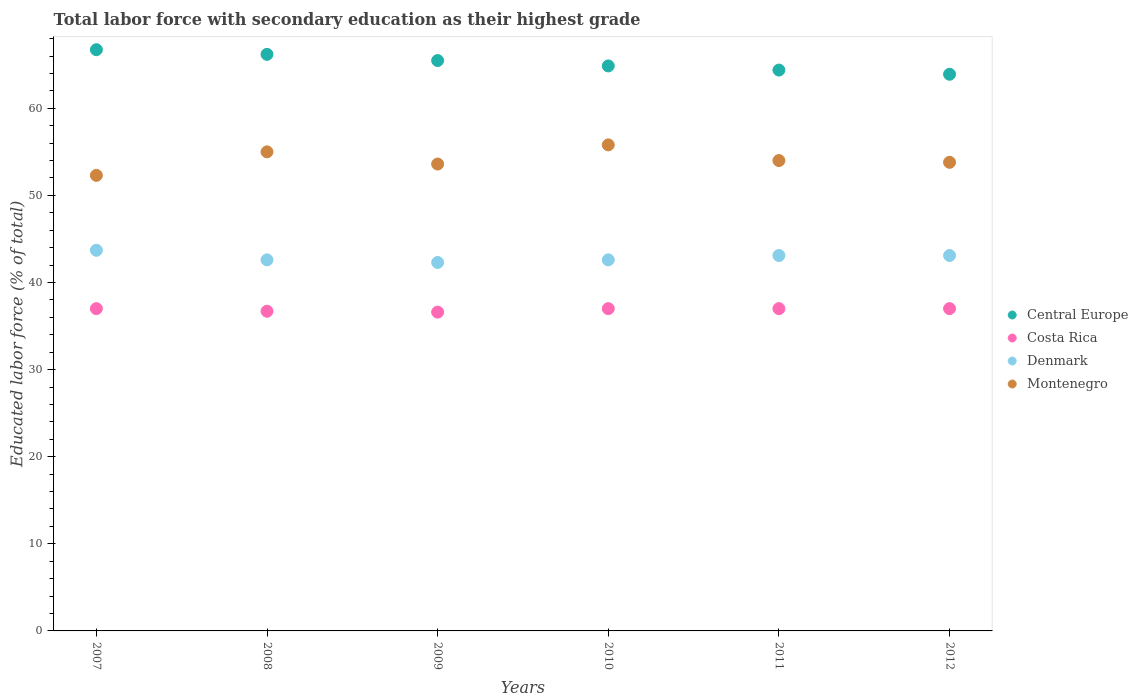How many different coloured dotlines are there?
Your response must be concise. 4. Is the number of dotlines equal to the number of legend labels?
Provide a short and direct response. Yes. What is the percentage of total labor force with primary education in Denmark in 2007?
Make the answer very short. 43.7. Across all years, what is the maximum percentage of total labor force with primary education in Montenegro?
Ensure brevity in your answer.  55.8. Across all years, what is the minimum percentage of total labor force with primary education in Central Europe?
Provide a succinct answer. 63.91. In which year was the percentage of total labor force with primary education in Central Europe maximum?
Your answer should be compact. 2007. In which year was the percentage of total labor force with primary education in Central Europe minimum?
Your answer should be compact. 2012. What is the total percentage of total labor force with primary education in Costa Rica in the graph?
Ensure brevity in your answer.  221.3. What is the difference between the percentage of total labor force with primary education in Montenegro in 2010 and that in 2011?
Your response must be concise. 1.8. What is the difference between the percentage of total labor force with primary education in Central Europe in 2007 and the percentage of total labor force with primary education in Costa Rica in 2010?
Provide a short and direct response. 29.73. What is the average percentage of total labor force with primary education in Montenegro per year?
Keep it short and to the point. 54.08. In the year 2007, what is the difference between the percentage of total labor force with primary education in Montenegro and percentage of total labor force with primary education in Denmark?
Make the answer very short. 8.6. What is the ratio of the percentage of total labor force with primary education in Denmark in 2007 to that in 2011?
Keep it short and to the point. 1.01. What is the difference between the highest and the second highest percentage of total labor force with primary education in Denmark?
Your response must be concise. 0.6. What is the difference between the highest and the lowest percentage of total labor force with primary education in Costa Rica?
Offer a terse response. 0.4. Is the sum of the percentage of total labor force with primary education in Denmark in 2011 and 2012 greater than the maximum percentage of total labor force with primary education in Montenegro across all years?
Provide a succinct answer. Yes. Does the percentage of total labor force with primary education in Central Europe monotonically increase over the years?
Your answer should be compact. No. Is the percentage of total labor force with primary education in Montenegro strictly greater than the percentage of total labor force with primary education in Denmark over the years?
Offer a terse response. Yes. Is the percentage of total labor force with primary education in Costa Rica strictly less than the percentage of total labor force with primary education in Central Europe over the years?
Your answer should be compact. Yes. How many years are there in the graph?
Provide a short and direct response. 6. Does the graph contain grids?
Make the answer very short. No. How many legend labels are there?
Provide a succinct answer. 4. How are the legend labels stacked?
Offer a very short reply. Vertical. What is the title of the graph?
Your answer should be compact. Total labor force with secondary education as their highest grade. What is the label or title of the X-axis?
Ensure brevity in your answer.  Years. What is the label or title of the Y-axis?
Make the answer very short. Educated labor force (% of total). What is the Educated labor force (% of total) in Central Europe in 2007?
Provide a short and direct response. 66.73. What is the Educated labor force (% of total) in Costa Rica in 2007?
Keep it short and to the point. 37. What is the Educated labor force (% of total) of Denmark in 2007?
Your answer should be compact. 43.7. What is the Educated labor force (% of total) in Montenegro in 2007?
Offer a very short reply. 52.3. What is the Educated labor force (% of total) of Central Europe in 2008?
Give a very brief answer. 66.19. What is the Educated labor force (% of total) of Costa Rica in 2008?
Provide a succinct answer. 36.7. What is the Educated labor force (% of total) in Denmark in 2008?
Make the answer very short. 42.6. What is the Educated labor force (% of total) of Montenegro in 2008?
Make the answer very short. 55. What is the Educated labor force (% of total) in Central Europe in 2009?
Ensure brevity in your answer.  65.48. What is the Educated labor force (% of total) in Costa Rica in 2009?
Give a very brief answer. 36.6. What is the Educated labor force (% of total) in Denmark in 2009?
Provide a short and direct response. 42.3. What is the Educated labor force (% of total) in Montenegro in 2009?
Ensure brevity in your answer.  53.6. What is the Educated labor force (% of total) in Central Europe in 2010?
Your answer should be compact. 64.87. What is the Educated labor force (% of total) in Denmark in 2010?
Provide a succinct answer. 42.6. What is the Educated labor force (% of total) in Montenegro in 2010?
Your answer should be very brief. 55.8. What is the Educated labor force (% of total) of Central Europe in 2011?
Provide a succinct answer. 64.39. What is the Educated labor force (% of total) of Costa Rica in 2011?
Make the answer very short. 37. What is the Educated labor force (% of total) of Denmark in 2011?
Make the answer very short. 43.1. What is the Educated labor force (% of total) in Montenegro in 2011?
Provide a short and direct response. 54. What is the Educated labor force (% of total) in Central Europe in 2012?
Keep it short and to the point. 63.91. What is the Educated labor force (% of total) of Costa Rica in 2012?
Your response must be concise. 37. What is the Educated labor force (% of total) in Denmark in 2012?
Offer a terse response. 43.1. What is the Educated labor force (% of total) of Montenegro in 2012?
Give a very brief answer. 53.8. Across all years, what is the maximum Educated labor force (% of total) in Central Europe?
Your response must be concise. 66.73. Across all years, what is the maximum Educated labor force (% of total) in Denmark?
Your answer should be compact. 43.7. Across all years, what is the maximum Educated labor force (% of total) of Montenegro?
Offer a terse response. 55.8. Across all years, what is the minimum Educated labor force (% of total) of Central Europe?
Your answer should be very brief. 63.91. Across all years, what is the minimum Educated labor force (% of total) of Costa Rica?
Provide a short and direct response. 36.6. Across all years, what is the minimum Educated labor force (% of total) of Denmark?
Your answer should be very brief. 42.3. Across all years, what is the minimum Educated labor force (% of total) of Montenegro?
Your response must be concise. 52.3. What is the total Educated labor force (% of total) in Central Europe in the graph?
Your answer should be compact. 391.57. What is the total Educated labor force (% of total) of Costa Rica in the graph?
Your response must be concise. 221.3. What is the total Educated labor force (% of total) in Denmark in the graph?
Offer a terse response. 257.4. What is the total Educated labor force (% of total) in Montenegro in the graph?
Your response must be concise. 324.5. What is the difference between the Educated labor force (% of total) in Central Europe in 2007 and that in 2008?
Provide a succinct answer. 0.53. What is the difference between the Educated labor force (% of total) of Costa Rica in 2007 and that in 2008?
Make the answer very short. 0.3. What is the difference between the Educated labor force (% of total) in Central Europe in 2007 and that in 2009?
Your answer should be compact. 1.25. What is the difference between the Educated labor force (% of total) in Costa Rica in 2007 and that in 2009?
Your answer should be very brief. 0.4. What is the difference between the Educated labor force (% of total) in Denmark in 2007 and that in 2009?
Your answer should be compact. 1.4. What is the difference between the Educated labor force (% of total) of Central Europe in 2007 and that in 2010?
Your response must be concise. 1.86. What is the difference between the Educated labor force (% of total) of Costa Rica in 2007 and that in 2010?
Give a very brief answer. 0. What is the difference between the Educated labor force (% of total) in Montenegro in 2007 and that in 2010?
Make the answer very short. -3.5. What is the difference between the Educated labor force (% of total) in Central Europe in 2007 and that in 2011?
Provide a short and direct response. 2.34. What is the difference between the Educated labor force (% of total) in Denmark in 2007 and that in 2011?
Offer a terse response. 0.6. What is the difference between the Educated labor force (% of total) in Central Europe in 2007 and that in 2012?
Your answer should be very brief. 2.82. What is the difference between the Educated labor force (% of total) of Costa Rica in 2007 and that in 2012?
Your answer should be compact. 0. What is the difference between the Educated labor force (% of total) in Denmark in 2007 and that in 2012?
Offer a very short reply. 0.6. What is the difference between the Educated labor force (% of total) in Montenegro in 2007 and that in 2012?
Provide a short and direct response. -1.5. What is the difference between the Educated labor force (% of total) in Central Europe in 2008 and that in 2009?
Offer a very short reply. 0.71. What is the difference between the Educated labor force (% of total) of Costa Rica in 2008 and that in 2009?
Your response must be concise. 0.1. What is the difference between the Educated labor force (% of total) in Central Europe in 2008 and that in 2010?
Offer a very short reply. 1.33. What is the difference between the Educated labor force (% of total) of Costa Rica in 2008 and that in 2010?
Your answer should be compact. -0.3. What is the difference between the Educated labor force (% of total) of Denmark in 2008 and that in 2010?
Your answer should be compact. 0. What is the difference between the Educated labor force (% of total) in Central Europe in 2008 and that in 2011?
Provide a succinct answer. 1.81. What is the difference between the Educated labor force (% of total) in Costa Rica in 2008 and that in 2011?
Make the answer very short. -0.3. What is the difference between the Educated labor force (% of total) in Denmark in 2008 and that in 2011?
Your answer should be very brief. -0.5. What is the difference between the Educated labor force (% of total) of Montenegro in 2008 and that in 2011?
Ensure brevity in your answer.  1. What is the difference between the Educated labor force (% of total) of Central Europe in 2008 and that in 2012?
Keep it short and to the point. 2.29. What is the difference between the Educated labor force (% of total) in Denmark in 2008 and that in 2012?
Provide a succinct answer. -0.5. What is the difference between the Educated labor force (% of total) in Central Europe in 2009 and that in 2010?
Offer a very short reply. 0.61. What is the difference between the Educated labor force (% of total) in Costa Rica in 2009 and that in 2010?
Provide a succinct answer. -0.4. What is the difference between the Educated labor force (% of total) of Denmark in 2009 and that in 2010?
Give a very brief answer. -0.3. What is the difference between the Educated labor force (% of total) of Central Europe in 2009 and that in 2011?
Your answer should be very brief. 1.09. What is the difference between the Educated labor force (% of total) in Costa Rica in 2009 and that in 2011?
Your response must be concise. -0.4. What is the difference between the Educated labor force (% of total) of Montenegro in 2009 and that in 2011?
Provide a short and direct response. -0.4. What is the difference between the Educated labor force (% of total) of Central Europe in 2009 and that in 2012?
Offer a terse response. 1.57. What is the difference between the Educated labor force (% of total) in Denmark in 2009 and that in 2012?
Your response must be concise. -0.8. What is the difference between the Educated labor force (% of total) in Central Europe in 2010 and that in 2011?
Offer a terse response. 0.48. What is the difference between the Educated labor force (% of total) in Costa Rica in 2010 and that in 2011?
Keep it short and to the point. 0. What is the difference between the Educated labor force (% of total) of Central Europe in 2010 and that in 2012?
Keep it short and to the point. 0.96. What is the difference between the Educated labor force (% of total) of Costa Rica in 2010 and that in 2012?
Provide a short and direct response. 0. What is the difference between the Educated labor force (% of total) of Montenegro in 2010 and that in 2012?
Make the answer very short. 2. What is the difference between the Educated labor force (% of total) in Central Europe in 2011 and that in 2012?
Make the answer very short. 0.48. What is the difference between the Educated labor force (% of total) of Montenegro in 2011 and that in 2012?
Offer a very short reply. 0.2. What is the difference between the Educated labor force (% of total) in Central Europe in 2007 and the Educated labor force (% of total) in Costa Rica in 2008?
Your answer should be compact. 30.03. What is the difference between the Educated labor force (% of total) in Central Europe in 2007 and the Educated labor force (% of total) in Denmark in 2008?
Offer a terse response. 24.13. What is the difference between the Educated labor force (% of total) in Central Europe in 2007 and the Educated labor force (% of total) in Montenegro in 2008?
Give a very brief answer. 11.73. What is the difference between the Educated labor force (% of total) of Costa Rica in 2007 and the Educated labor force (% of total) of Denmark in 2008?
Your response must be concise. -5.6. What is the difference between the Educated labor force (% of total) in Denmark in 2007 and the Educated labor force (% of total) in Montenegro in 2008?
Provide a succinct answer. -11.3. What is the difference between the Educated labor force (% of total) in Central Europe in 2007 and the Educated labor force (% of total) in Costa Rica in 2009?
Your answer should be compact. 30.13. What is the difference between the Educated labor force (% of total) in Central Europe in 2007 and the Educated labor force (% of total) in Denmark in 2009?
Offer a very short reply. 24.43. What is the difference between the Educated labor force (% of total) of Central Europe in 2007 and the Educated labor force (% of total) of Montenegro in 2009?
Provide a succinct answer. 13.13. What is the difference between the Educated labor force (% of total) in Costa Rica in 2007 and the Educated labor force (% of total) in Montenegro in 2009?
Your answer should be very brief. -16.6. What is the difference between the Educated labor force (% of total) of Denmark in 2007 and the Educated labor force (% of total) of Montenegro in 2009?
Provide a succinct answer. -9.9. What is the difference between the Educated labor force (% of total) in Central Europe in 2007 and the Educated labor force (% of total) in Costa Rica in 2010?
Your answer should be very brief. 29.73. What is the difference between the Educated labor force (% of total) in Central Europe in 2007 and the Educated labor force (% of total) in Denmark in 2010?
Your answer should be compact. 24.13. What is the difference between the Educated labor force (% of total) of Central Europe in 2007 and the Educated labor force (% of total) of Montenegro in 2010?
Your answer should be compact. 10.93. What is the difference between the Educated labor force (% of total) of Costa Rica in 2007 and the Educated labor force (% of total) of Montenegro in 2010?
Offer a very short reply. -18.8. What is the difference between the Educated labor force (% of total) in Denmark in 2007 and the Educated labor force (% of total) in Montenegro in 2010?
Offer a terse response. -12.1. What is the difference between the Educated labor force (% of total) of Central Europe in 2007 and the Educated labor force (% of total) of Costa Rica in 2011?
Keep it short and to the point. 29.73. What is the difference between the Educated labor force (% of total) in Central Europe in 2007 and the Educated labor force (% of total) in Denmark in 2011?
Make the answer very short. 23.63. What is the difference between the Educated labor force (% of total) of Central Europe in 2007 and the Educated labor force (% of total) of Montenegro in 2011?
Offer a very short reply. 12.73. What is the difference between the Educated labor force (% of total) in Costa Rica in 2007 and the Educated labor force (% of total) in Montenegro in 2011?
Your response must be concise. -17. What is the difference between the Educated labor force (% of total) of Central Europe in 2007 and the Educated labor force (% of total) of Costa Rica in 2012?
Give a very brief answer. 29.73. What is the difference between the Educated labor force (% of total) of Central Europe in 2007 and the Educated labor force (% of total) of Denmark in 2012?
Provide a succinct answer. 23.63. What is the difference between the Educated labor force (% of total) in Central Europe in 2007 and the Educated labor force (% of total) in Montenegro in 2012?
Provide a short and direct response. 12.93. What is the difference between the Educated labor force (% of total) in Costa Rica in 2007 and the Educated labor force (% of total) in Denmark in 2012?
Offer a terse response. -6.1. What is the difference between the Educated labor force (% of total) of Costa Rica in 2007 and the Educated labor force (% of total) of Montenegro in 2012?
Give a very brief answer. -16.8. What is the difference between the Educated labor force (% of total) of Denmark in 2007 and the Educated labor force (% of total) of Montenegro in 2012?
Keep it short and to the point. -10.1. What is the difference between the Educated labor force (% of total) of Central Europe in 2008 and the Educated labor force (% of total) of Costa Rica in 2009?
Give a very brief answer. 29.59. What is the difference between the Educated labor force (% of total) of Central Europe in 2008 and the Educated labor force (% of total) of Denmark in 2009?
Your answer should be very brief. 23.89. What is the difference between the Educated labor force (% of total) in Central Europe in 2008 and the Educated labor force (% of total) in Montenegro in 2009?
Offer a very short reply. 12.59. What is the difference between the Educated labor force (% of total) of Costa Rica in 2008 and the Educated labor force (% of total) of Denmark in 2009?
Provide a succinct answer. -5.6. What is the difference between the Educated labor force (% of total) of Costa Rica in 2008 and the Educated labor force (% of total) of Montenegro in 2009?
Make the answer very short. -16.9. What is the difference between the Educated labor force (% of total) of Central Europe in 2008 and the Educated labor force (% of total) of Costa Rica in 2010?
Offer a terse response. 29.19. What is the difference between the Educated labor force (% of total) of Central Europe in 2008 and the Educated labor force (% of total) of Denmark in 2010?
Your answer should be very brief. 23.59. What is the difference between the Educated labor force (% of total) in Central Europe in 2008 and the Educated labor force (% of total) in Montenegro in 2010?
Make the answer very short. 10.39. What is the difference between the Educated labor force (% of total) in Costa Rica in 2008 and the Educated labor force (% of total) in Montenegro in 2010?
Your answer should be very brief. -19.1. What is the difference between the Educated labor force (% of total) in Denmark in 2008 and the Educated labor force (% of total) in Montenegro in 2010?
Provide a short and direct response. -13.2. What is the difference between the Educated labor force (% of total) of Central Europe in 2008 and the Educated labor force (% of total) of Costa Rica in 2011?
Offer a terse response. 29.19. What is the difference between the Educated labor force (% of total) in Central Europe in 2008 and the Educated labor force (% of total) in Denmark in 2011?
Keep it short and to the point. 23.09. What is the difference between the Educated labor force (% of total) in Central Europe in 2008 and the Educated labor force (% of total) in Montenegro in 2011?
Offer a terse response. 12.19. What is the difference between the Educated labor force (% of total) in Costa Rica in 2008 and the Educated labor force (% of total) in Denmark in 2011?
Offer a very short reply. -6.4. What is the difference between the Educated labor force (% of total) of Costa Rica in 2008 and the Educated labor force (% of total) of Montenegro in 2011?
Your answer should be very brief. -17.3. What is the difference between the Educated labor force (% of total) in Denmark in 2008 and the Educated labor force (% of total) in Montenegro in 2011?
Keep it short and to the point. -11.4. What is the difference between the Educated labor force (% of total) of Central Europe in 2008 and the Educated labor force (% of total) of Costa Rica in 2012?
Provide a short and direct response. 29.19. What is the difference between the Educated labor force (% of total) of Central Europe in 2008 and the Educated labor force (% of total) of Denmark in 2012?
Your response must be concise. 23.09. What is the difference between the Educated labor force (% of total) in Central Europe in 2008 and the Educated labor force (% of total) in Montenegro in 2012?
Ensure brevity in your answer.  12.39. What is the difference between the Educated labor force (% of total) in Costa Rica in 2008 and the Educated labor force (% of total) in Montenegro in 2012?
Your answer should be compact. -17.1. What is the difference between the Educated labor force (% of total) in Central Europe in 2009 and the Educated labor force (% of total) in Costa Rica in 2010?
Keep it short and to the point. 28.48. What is the difference between the Educated labor force (% of total) of Central Europe in 2009 and the Educated labor force (% of total) of Denmark in 2010?
Give a very brief answer. 22.88. What is the difference between the Educated labor force (% of total) of Central Europe in 2009 and the Educated labor force (% of total) of Montenegro in 2010?
Your answer should be very brief. 9.68. What is the difference between the Educated labor force (% of total) in Costa Rica in 2009 and the Educated labor force (% of total) in Denmark in 2010?
Your answer should be compact. -6. What is the difference between the Educated labor force (% of total) in Costa Rica in 2009 and the Educated labor force (% of total) in Montenegro in 2010?
Offer a very short reply. -19.2. What is the difference between the Educated labor force (% of total) in Central Europe in 2009 and the Educated labor force (% of total) in Costa Rica in 2011?
Offer a terse response. 28.48. What is the difference between the Educated labor force (% of total) in Central Europe in 2009 and the Educated labor force (% of total) in Denmark in 2011?
Your answer should be very brief. 22.38. What is the difference between the Educated labor force (% of total) in Central Europe in 2009 and the Educated labor force (% of total) in Montenegro in 2011?
Ensure brevity in your answer.  11.48. What is the difference between the Educated labor force (% of total) of Costa Rica in 2009 and the Educated labor force (% of total) of Montenegro in 2011?
Your response must be concise. -17.4. What is the difference between the Educated labor force (% of total) of Central Europe in 2009 and the Educated labor force (% of total) of Costa Rica in 2012?
Provide a succinct answer. 28.48. What is the difference between the Educated labor force (% of total) in Central Europe in 2009 and the Educated labor force (% of total) in Denmark in 2012?
Provide a short and direct response. 22.38. What is the difference between the Educated labor force (% of total) of Central Europe in 2009 and the Educated labor force (% of total) of Montenegro in 2012?
Keep it short and to the point. 11.68. What is the difference between the Educated labor force (% of total) in Costa Rica in 2009 and the Educated labor force (% of total) in Denmark in 2012?
Offer a very short reply. -6.5. What is the difference between the Educated labor force (% of total) of Costa Rica in 2009 and the Educated labor force (% of total) of Montenegro in 2012?
Your answer should be very brief. -17.2. What is the difference between the Educated labor force (% of total) in Central Europe in 2010 and the Educated labor force (% of total) in Costa Rica in 2011?
Your answer should be compact. 27.87. What is the difference between the Educated labor force (% of total) of Central Europe in 2010 and the Educated labor force (% of total) of Denmark in 2011?
Your answer should be very brief. 21.77. What is the difference between the Educated labor force (% of total) in Central Europe in 2010 and the Educated labor force (% of total) in Montenegro in 2011?
Your response must be concise. 10.87. What is the difference between the Educated labor force (% of total) of Costa Rica in 2010 and the Educated labor force (% of total) of Montenegro in 2011?
Make the answer very short. -17. What is the difference between the Educated labor force (% of total) of Denmark in 2010 and the Educated labor force (% of total) of Montenegro in 2011?
Provide a succinct answer. -11.4. What is the difference between the Educated labor force (% of total) in Central Europe in 2010 and the Educated labor force (% of total) in Costa Rica in 2012?
Keep it short and to the point. 27.87. What is the difference between the Educated labor force (% of total) of Central Europe in 2010 and the Educated labor force (% of total) of Denmark in 2012?
Make the answer very short. 21.77. What is the difference between the Educated labor force (% of total) in Central Europe in 2010 and the Educated labor force (% of total) in Montenegro in 2012?
Your response must be concise. 11.07. What is the difference between the Educated labor force (% of total) in Costa Rica in 2010 and the Educated labor force (% of total) in Montenegro in 2012?
Ensure brevity in your answer.  -16.8. What is the difference between the Educated labor force (% of total) of Denmark in 2010 and the Educated labor force (% of total) of Montenegro in 2012?
Make the answer very short. -11.2. What is the difference between the Educated labor force (% of total) in Central Europe in 2011 and the Educated labor force (% of total) in Costa Rica in 2012?
Your answer should be very brief. 27.39. What is the difference between the Educated labor force (% of total) in Central Europe in 2011 and the Educated labor force (% of total) in Denmark in 2012?
Offer a terse response. 21.29. What is the difference between the Educated labor force (% of total) in Central Europe in 2011 and the Educated labor force (% of total) in Montenegro in 2012?
Provide a succinct answer. 10.59. What is the difference between the Educated labor force (% of total) in Costa Rica in 2011 and the Educated labor force (% of total) in Montenegro in 2012?
Provide a succinct answer. -16.8. What is the difference between the Educated labor force (% of total) of Denmark in 2011 and the Educated labor force (% of total) of Montenegro in 2012?
Ensure brevity in your answer.  -10.7. What is the average Educated labor force (% of total) in Central Europe per year?
Your answer should be compact. 65.26. What is the average Educated labor force (% of total) in Costa Rica per year?
Ensure brevity in your answer.  36.88. What is the average Educated labor force (% of total) of Denmark per year?
Offer a terse response. 42.9. What is the average Educated labor force (% of total) of Montenegro per year?
Your answer should be compact. 54.08. In the year 2007, what is the difference between the Educated labor force (% of total) in Central Europe and Educated labor force (% of total) in Costa Rica?
Give a very brief answer. 29.73. In the year 2007, what is the difference between the Educated labor force (% of total) of Central Europe and Educated labor force (% of total) of Denmark?
Offer a very short reply. 23.03. In the year 2007, what is the difference between the Educated labor force (% of total) of Central Europe and Educated labor force (% of total) of Montenegro?
Your answer should be very brief. 14.43. In the year 2007, what is the difference between the Educated labor force (% of total) of Costa Rica and Educated labor force (% of total) of Denmark?
Your answer should be compact. -6.7. In the year 2007, what is the difference between the Educated labor force (% of total) of Costa Rica and Educated labor force (% of total) of Montenegro?
Offer a very short reply. -15.3. In the year 2008, what is the difference between the Educated labor force (% of total) in Central Europe and Educated labor force (% of total) in Costa Rica?
Provide a short and direct response. 29.49. In the year 2008, what is the difference between the Educated labor force (% of total) of Central Europe and Educated labor force (% of total) of Denmark?
Provide a short and direct response. 23.59. In the year 2008, what is the difference between the Educated labor force (% of total) in Central Europe and Educated labor force (% of total) in Montenegro?
Offer a terse response. 11.19. In the year 2008, what is the difference between the Educated labor force (% of total) of Costa Rica and Educated labor force (% of total) of Montenegro?
Offer a terse response. -18.3. In the year 2008, what is the difference between the Educated labor force (% of total) of Denmark and Educated labor force (% of total) of Montenegro?
Your answer should be compact. -12.4. In the year 2009, what is the difference between the Educated labor force (% of total) of Central Europe and Educated labor force (% of total) of Costa Rica?
Make the answer very short. 28.88. In the year 2009, what is the difference between the Educated labor force (% of total) of Central Europe and Educated labor force (% of total) of Denmark?
Offer a very short reply. 23.18. In the year 2009, what is the difference between the Educated labor force (% of total) of Central Europe and Educated labor force (% of total) of Montenegro?
Offer a very short reply. 11.88. In the year 2009, what is the difference between the Educated labor force (% of total) of Costa Rica and Educated labor force (% of total) of Denmark?
Your response must be concise. -5.7. In the year 2009, what is the difference between the Educated labor force (% of total) in Costa Rica and Educated labor force (% of total) in Montenegro?
Provide a succinct answer. -17. In the year 2009, what is the difference between the Educated labor force (% of total) of Denmark and Educated labor force (% of total) of Montenegro?
Make the answer very short. -11.3. In the year 2010, what is the difference between the Educated labor force (% of total) in Central Europe and Educated labor force (% of total) in Costa Rica?
Give a very brief answer. 27.87. In the year 2010, what is the difference between the Educated labor force (% of total) of Central Europe and Educated labor force (% of total) of Denmark?
Keep it short and to the point. 22.27. In the year 2010, what is the difference between the Educated labor force (% of total) in Central Europe and Educated labor force (% of total) in Montenegro?
Provide a succinct answer. 9.07. In the year 2010, what is the difference between the Educated labor force (% of total) in Costa Rica and Educated labor force (% of total) in Denmark?
Your response must be concise. -5.6. In the year 2010, what is the difference between the Educated labor force (% of total) in Costa Rica and Educated labor force (% of total) in Montenegro?
Offer a terse response. -18.8. In the year 2010, what is the difference between the Educated labor force (% of total) in Denmark and Educated labor force (% of total) in Montenegro?
Provide a short and direct response. -13.2. In the year 2011, what is the difference between the Educated labor force (% of total) in Central Europe and Educated labor force (% of total) in Costa Rica?
Offer a terse response. 27.39. In the year 2011, what is the difference between the Educated labor force (% of total) of Central Europe and Educated labor force (% of total) of Denmark?
Offer a terse response. 21.29. In the year 2011, what is the difference between the Educated labor force (% of total) of Central Europe and Educated labor force (% of total) of Montenegro?
Your response must be concise. 10.39. In the year 2011, what is the difference between the Educated labor force (% of total) of Costa Rica and Educated labor force (% of total) of Montenegro?
Offer a terse response. -17. In the year 2011, what is the difference between the Educated labor force (% of total) in Denmark and Educated labor force (% of total) in Montenegro?
Ensure brevity in your answer.  -10.9. In the year 2012, what is the difference between the Educated labor force (% of total) in Central Europe and Educated labor force (% of total) in Costa Rica?
Ensure brevity in your answer.  26.91. In the year 2012, what is the difference between the Educated labor force (% of total) in Central Europe and Educated labor force (% of total) in Denmark?
Your answer should be very brief. 20.81. In the year 2012, what is the difference between the Educated labor force (% of total) of Central Europe and Educated labor force (% of total) of Montenegro?
Provide a succinct answer. 10.11. In the year 2012, what is the difference between the Educated labor force (% of total) of Costa Rica and Educated labor force (% of total) of Denmark?
Your answer should be compact. -6.1. In the year 2012, what is the difference between the Educated labor force (% of total) of Costa Rica and Educated labor force (% of total) of Montenegro?
Ensure brevity in your answer.  -16.8. In the year 2012, what is the difference between the Educated labor force (% of total) in Denmark and Educated labor force (% of total) in Montenegro?
Your answer should be compact. -10.7. What is the ratio of the Educated labor force (% of total) in Costa Rica in 2007 to that in 2008?
Your answer should be compact. 1.01. What is the ratio of the Educated labor force (% of total) in Denmark in 2007 to that in 2008?
Keep it short and to the point. 1.03. What is the ratio of the Educated labor force (% of total) of Montenegro in 2007 to that in 2008?
Your answer should be compact. 0.95. What is the ratio of the Educated labor force (% of total) in Central Europe in 2007 to that in 2009?
Provide a succinct answer. 1.02. What is the ratio of the Educated labor force (% of total) in Costa Rica in 2007 to that in 2009?
Keep it short and to the point. 1.01. What is the ratio of the Educated labor force (% of total) in Denmark in 2007 to that in 2009?
Your response must be concise. 1.03. What is the ratio of the Educated labor force (% of total) in Montenegro in 2007 to that in 2009?
Your response must be concise. 0.98. What is the ratio of the Educated labor force (% of total) in Central Europe in 2007 to that in 2010?
Make the answer very short. 1.03. What is the ratio of the Educated labor force (% of total) in Denmark in 2007 to that in 2010?
Your response must be concise. 1.03. What is the ratio of the Educated labor force (% of total) of Montenegro in 2007 to that in 2010?
Your answer should be very brief. 0.94. What is the ratio of the Educated labor force (% of total) of Central Europe in 2007 to that in 2011?
Your response must be concise. 1.04. What is the ratio of the Educated labor force (% of total) of Denmark in 2007 to that in 2011?
Offer a terse response. 1.01. What is the ratio of the Educated labor force (% of total) in Montenegro in 2007 to that in 2011?
Offer a very short reply. 0.97. What is the ratio of the Educated labor force (% of total) of Central Europe in 2007 to that in 2012?
Provide a short and direct response. 1.04. What is the ratio of the Educated labor force (% of total) in Costa Rica in 2007 to that in 2012?
Give a very brief answer. 1. What is the ratio of the Educated labor force (% of total) of Denmark in 2007 to that in 2012?
Give a very brief answer. 1.01. What is the ratio of the Educated labor force (% of total) of Montenegro in 2007 to that in 2012?
Provide a short and direct response. 0.97. What is the ratio of the Educated labor force (% of total) in Central Europe in 2008 to that in 2009?
Make the answer very short. 1.01. What is the ratio of the Educated labor force (% of total) in Denmark in 2008 to that in 2009?
Provide a short and direct response. 1.01. What is the ratio of the Educated labor force (% of total) of Montenegro in 2008 to that in 2009?
Your answer should be compact. 1.03. What is the ratio of the Educated labor force (% of total) in Central Europe in 2008 to that in 2010?
Give a very brief answer. 1.02. What is the ratio of the Educated labor force (% of total) in Montenegro in 2008 to that in 2010?
Make the answer very short. 0.99. What is the ratio of the Educated labor force (% of total) of Central Europe in 2008 to that in 2011?
Provide a short and direct response. 1.03. What is the ratio of the Educated labor force (% of total) of Denmark in 2008 to that in 2011?
Your response must be concise. 0.99. What is the ratio of the Educated labor force (% of total) of Montenegro in 2008 to that in 2011?
Your response must be concise. 1.02. What is the ratio of the Educated labor force (% of total) of Central Europe in 2008 to that in 2012?
Your response must be concise. 1.04. What is the ratio of the Educated labor force (% of total) in Denmark in 2008 to that in 2012?
Your response must be concise. 0.99. What is the ratio of the Educated labor force (% of total) of Montenegro in 2008 to that in 2012?
Provide a succinct answer. 1.02. What is the ratio of the Educated labor force (% of total) in Central Europe in 2009 to that in 2010?
Provide a succinct answer. 1.01. What is the ratio of the Educated labor force (% of total) in Montenegro in 2009 to that in 2010?
Offer a very short reply. 0.96. What is the ratio of the Educated labor force (% of total) of Central Europe in 2009 to that in 2011?
Make the answer very short. 1.02. What is the ratio of the Educated labor force (% of total) in Costa Rica in 2009 to that in 2011?
Provide a succinct answer. 0.99. What is the ratio of the Educated labor force (% of total) of Denmark in 2009 to that in 2011?
Offer a very short reply. 0.98. What is the ratio of the Educated labor force (% of total) of Central Europe in 2009 to that in 2012?
Keep it short and to the point. 1.02. What is the ratio of the Educated labor force (% of total) of Costa Rica in 2009 to that in 2012?
Give a very brief answer. 0.99. What is the ratio of the Educated labor force (% of total) in Denmark in 2009 to that in 2012?
Your answer should be compact. 0.98. What is the ratio of the Educated labor force (% of total) in Montenegro in 2009 to that in 2012?
Give a very brief answer. 1. What is the ratio of the Educated labor force (% of total) in Central Europe in 2010 to that in 2011?
Offer a terse response. 1.01. What is the ratio of the Educated labor force (% of total) in Costa Rica in 2010 to that in 2011?
Provide a short and direct response. 1. What is the ratio of the Educated labor force (% of total) in Denmark in 2010 to that in 2011?
Offer a very short reply. 0.99. What is the ratio of the Educated labor force (% of total) of Montenegro in 2010 to that in 2011?
Your answer should be very brief. 1.03. What is the ratio of the Educated labor force (% of total) of Central Europe in 2010 to that in 2012?
Make the answer very short. 1.01. What is the ratio of the Educated labor force (% of total) in Denmark in 2010 to that in 2012?
Offer a terse response. 0.99. What is the ratio of the Educated labor force (% of total) of Montenegro in 2010 to that in 2012?
Your answer should be very brief. 1.04. What is the ratio of the Educated labor force (% of total) of Central Europe in 2011 to that in 2012?
Provide a short and direct response. 1.01. What is the difference between the highest and the second highest Educated labor force (% of total) in Central Europe?
Offer a very short reply. 0.53. What is the difference between the highest and the second highest Educated labor force (% of total) in Denmark?
Provide a short and direct response. 0.6. What is the difference between the highest and the lowest Educated labor force (% of total) in Central Europe?
Offer a terse response. 2.82. What is the difference between the highest and the lowest Educated labor force (% of total) in Costa Rica?
Your response must be concise. 0.4. What is the difference between the highest and the lowest Educated labor force (% of total) in Denmark?
Provide a short and direct response. 1.4. What is the difference between the highest and the lowest Educated labor force (% of total) of Montenegro?
Make the answer very short. 3.5. 